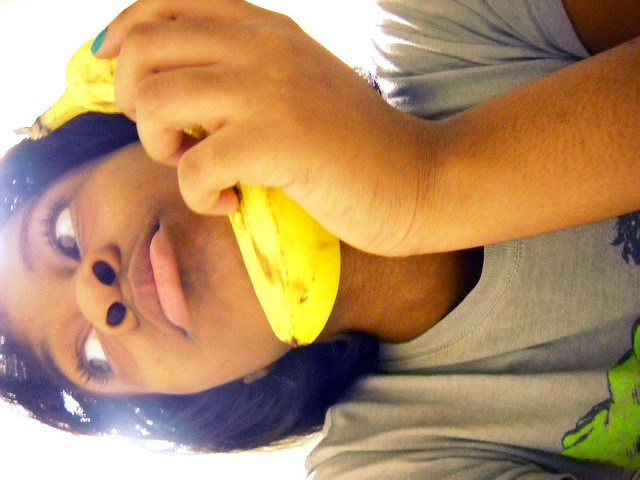Describe the objects in this image and their specific colors. I can see people in orange, ivory, brown, tan, and gray tones and banana in ivory, yellow, khaki, and orange tones in this image. 